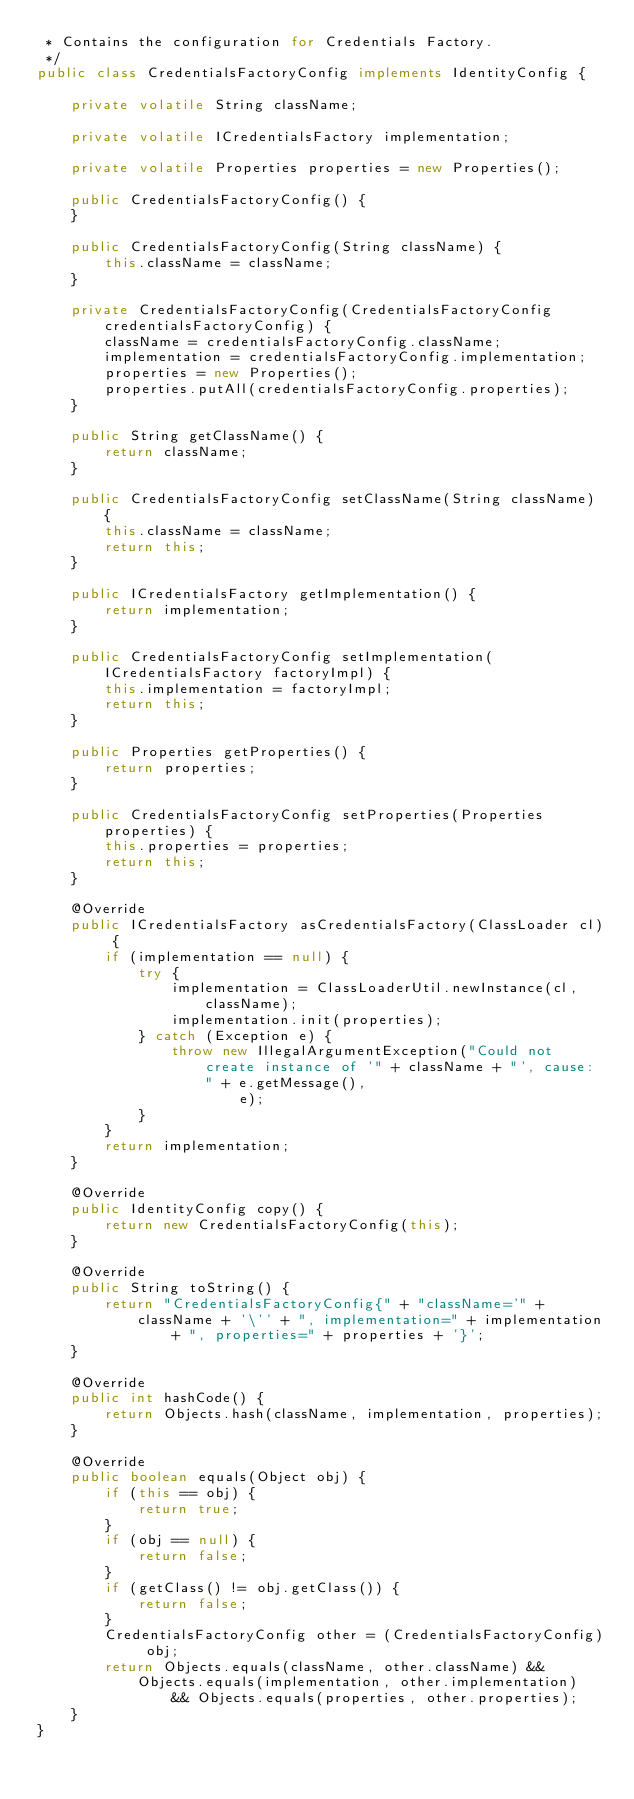Convert code to text. <code><loc_0><loc_0><loc_500><loc_500><_Java_> * Contains the configuration for Credentials Factory.
 */
public class CredentialsFactoryConfig implements IdentityConfig {

    private volatile String className;

    private volatile ICredentialsFactory implementation;

    private volatile Properties properties = new Properties();

    public CredentialsFactoryConfig() {
    }

    public CredentialsFactoryConfig(String className) {
        this.className = className;
    }

    private CredentialsFactoryConfig(CredentialsFactoryConfig credentialsFactoryConfig) {
        className = credentialsFactoryConfig.className;
        implementation = credentialsFactoryConfig.implementation;
        properties = new Properties();
        properties.putAll(credentialsFactoryConfig.properties);
    }

    public String getClassName() {
        return className;
    }

    public CredentialsFactoryConfig setClassName(String className) {
        this.className = className;
        return this;
    }

    public ICredentialsFactory getImplementation() {
        return implementation;
    }

    public CredentialsFactoryConfig setImplementation(ICredentialsFactory factoryImpl) {
        this.implementation = factoryImpl;
        return this;
    }

    public Properties getProperties() {
        return properties;
    }

    public CredentialsFactoryConfig setProperties(Properties properties) {
        this.properties = properties;
        return this;
    }

    @Override
    public ICredentialsFactory asCredentialsFactory(ClassLoader cl) {
        if (implementation == null) {
            try {
                implementation = ClassLoaderUtil.newInstance(cl, className);
                implementation.init(properties);
            } catch (Exception e) {
                throw new IllegalArgumentException("Could not create instance of '" + className + "', cause: " + e.getMessage(),
                        e);
            }
        }
        return implementation;
    }

    @Override
    public IdentityConfig copy() {
        return new CredentialsFactoryConfig(this);
    }

    @Override
    public String toString() {
        return "CredentialsFactoryConfig{" + "className='" + className + '\'' + ", implementation=" + implementation
                + ", properties=" + properties + '}';
    }

    @Override
    public int hashCode() {
        return Objects.hash(className, implementation, properties);
    }

    @Override
    public boolean equals(Object obj) {
        if (this == obj) {
            return true;
        }
        if (obj == null) {
            return false;
        }
        if (getClass() != obj.getClass()) {
            return false;
        }
        CredentialsFactoryConfig other = (CredentialsFactoryConfig) obj;
        return Objects.equals(className, other.className) && Objects.equals(implementation, other.implementation)
                && Objects.equals(properties, other.properties);
    }
}
</code> 